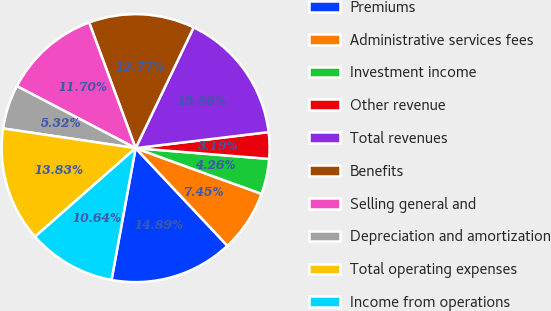Convert chart to OTSL. <chart><loc_0><loc_0><loc_500><loc_500><pie_chart><fcel>Premiums<fcel>Administrative services fees<fcel>Investment income<fcel>Other revenue<fcel>Total revenues<fcel>Benefits<fcel>Selling general and<fcel>Depreciation and amortization<fcel>Total operating expenses<fcel>Income from operations<nl><fcel>14.89%<fcel>7.45%<fcel>4.26%<fcel>3.19%<fcel>15.96%<fcel>12.77%<fcel>11.7%<fcel>5.32%<fcel>13.83%<fcel>10.64%<nl></chart> 